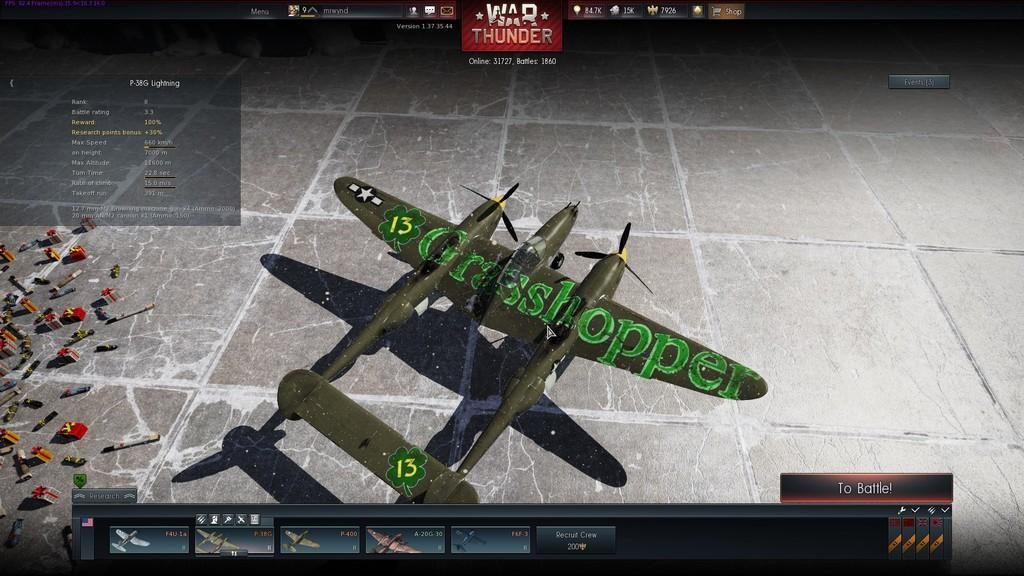What type of game is depicted in the image? There is a video game in the image. What is the main subject of the video game? The video game features an aircraft. Are there any additional objects near the video game? Yes, there are objects placed near the video game. What can be seen at the top of the image? There is a scoreboard visible at the top of the image. How many toes are visible on the aircraft in the image? There are no toes visible in the image, as it features a video game with an aircraft and not a living being. 